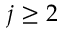Convert formula to latex. <formula><loc_0><loc_0><loc_500><loc_500>j \geq 2</formula> 